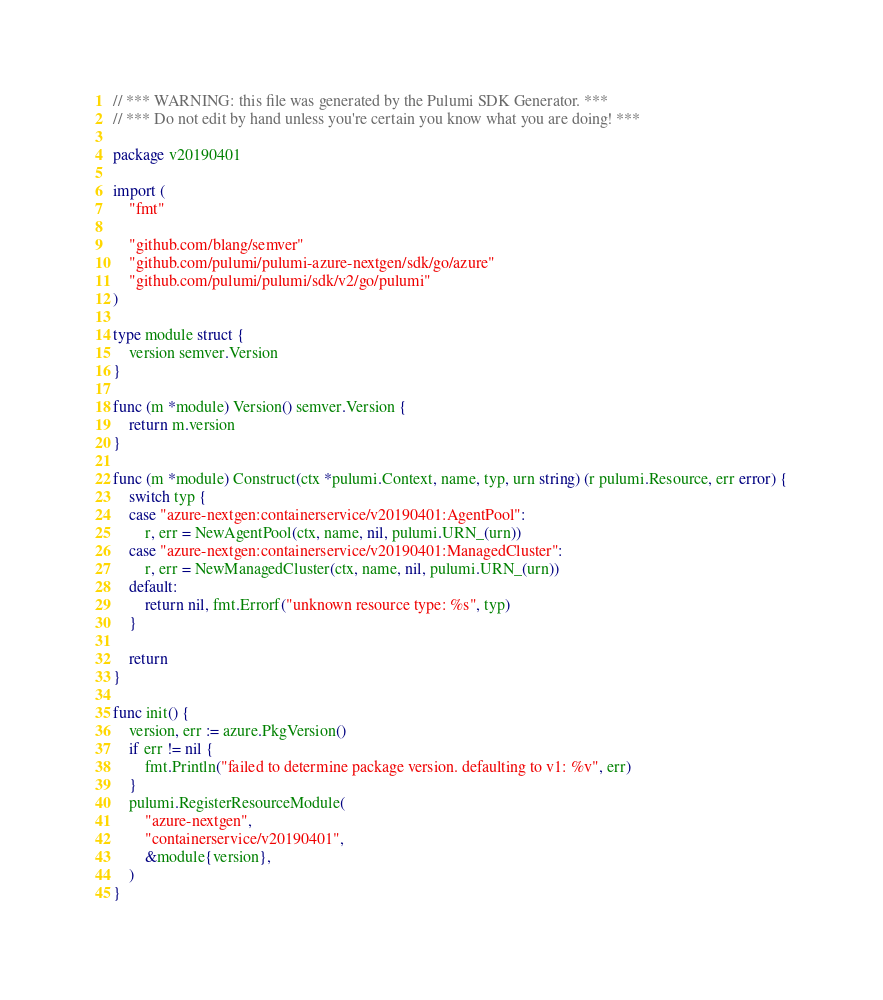Convert code to text. <code><loc_0><loc_0><loc_500><loc_500><_Go_>// *** WARNING: this file was generated by the Pulumi SDK Generator. ***
// *** Do not edit by hand unless you're certain you know what you are doing! ***

package v20190401

import (
	"fmt"

	"github.com/blang/semver"
	"github.com/pulumi/pulumi-azure-nextgen/sdk/go/azure"
	"github.com/pulumi/pulumi/sdk/v2/go/pulumi"
)

type module struct {
	version semver.Version
}

func (m *module) Version() semver.Version {
	return m.version
}

func (m *module) Construct(ctx *pulumi.Context, name, typ, urn string) (r pulumi.Resource, err error) {
	switch typ {
	case "azure-nextgen:containerservice/v20190401:AgentPool":
		r, err = NewAgentPool(ctx, name, nil, pulumi.URN_(urn))
	case "azure-nextgen:containerservice/v20190401:ManagedCluster":
		r, err = NewManagedCluster(ctx, name, nil, pulumi.URN_(urn))
	default:
		return nil, fmt.Errorf("unknown resource type: %s", typ)
	}

	return
}

func init() {
	version, err := azure.PkgVersion()
	if err != nil {
		fmt.Println("failed to determine package version. defaulting to v1: %v", err)
	}
	pulumi.RegisterResourceModule(
		"azure-nextgen",
		"containerservice/v20190401",
		&module{version},
	)
}
</code> 